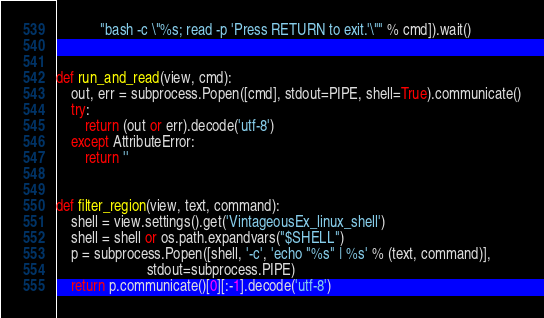<code> <loc_0><loc_0><loc_500><loc_500><_Python_>            "bash -c \"%s; read -p 'Press RETURN to exit.'\"" % cmd]).wait()


def run_and_read(view, cmd):
    out, err = subprocess.Popen([cmd], stdout=PIPE, shell=True).communicate()
    try:
        return (out or err).decode('utf-8')
    except AttributeError:
        return ''


def filter_region(view, text, command):
    shell = view.settings().get('VintageousEx_linux_shell')
    shell = shell or os.path.expandvars("$SHELL")
    p = subprocess.Popen([shell, '-c', 'echo "%s" | %s' % (text, command)],
                         stdout=subprocess.PIPE)
    return p.communicate()[0][:-1].decode('utf-8')
</code> 